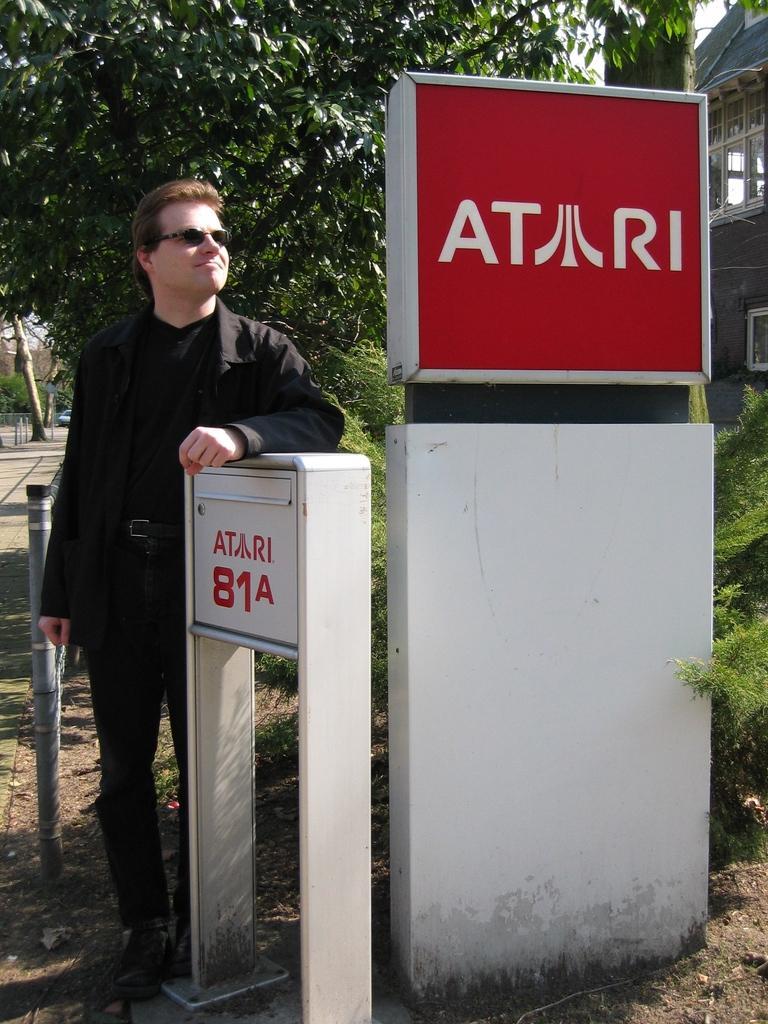Could you give a brief overview of what you see in this image? This picture is clicked outside. On the right there are two boards attached to the stands and the text is printed on the boards. On the left there is a person wearing black color blazer and standing on the ground. In the background we can see the trees, building, plants and some other objects. 